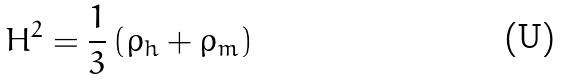Convert formula to latex. <formula><loc_0><loc_0><loc_500><loc_500>H ^ { 2 } = \frac { 1 } { 3 } \left ( \rho _ { h } + \rho _ { m } \right )</formula> 